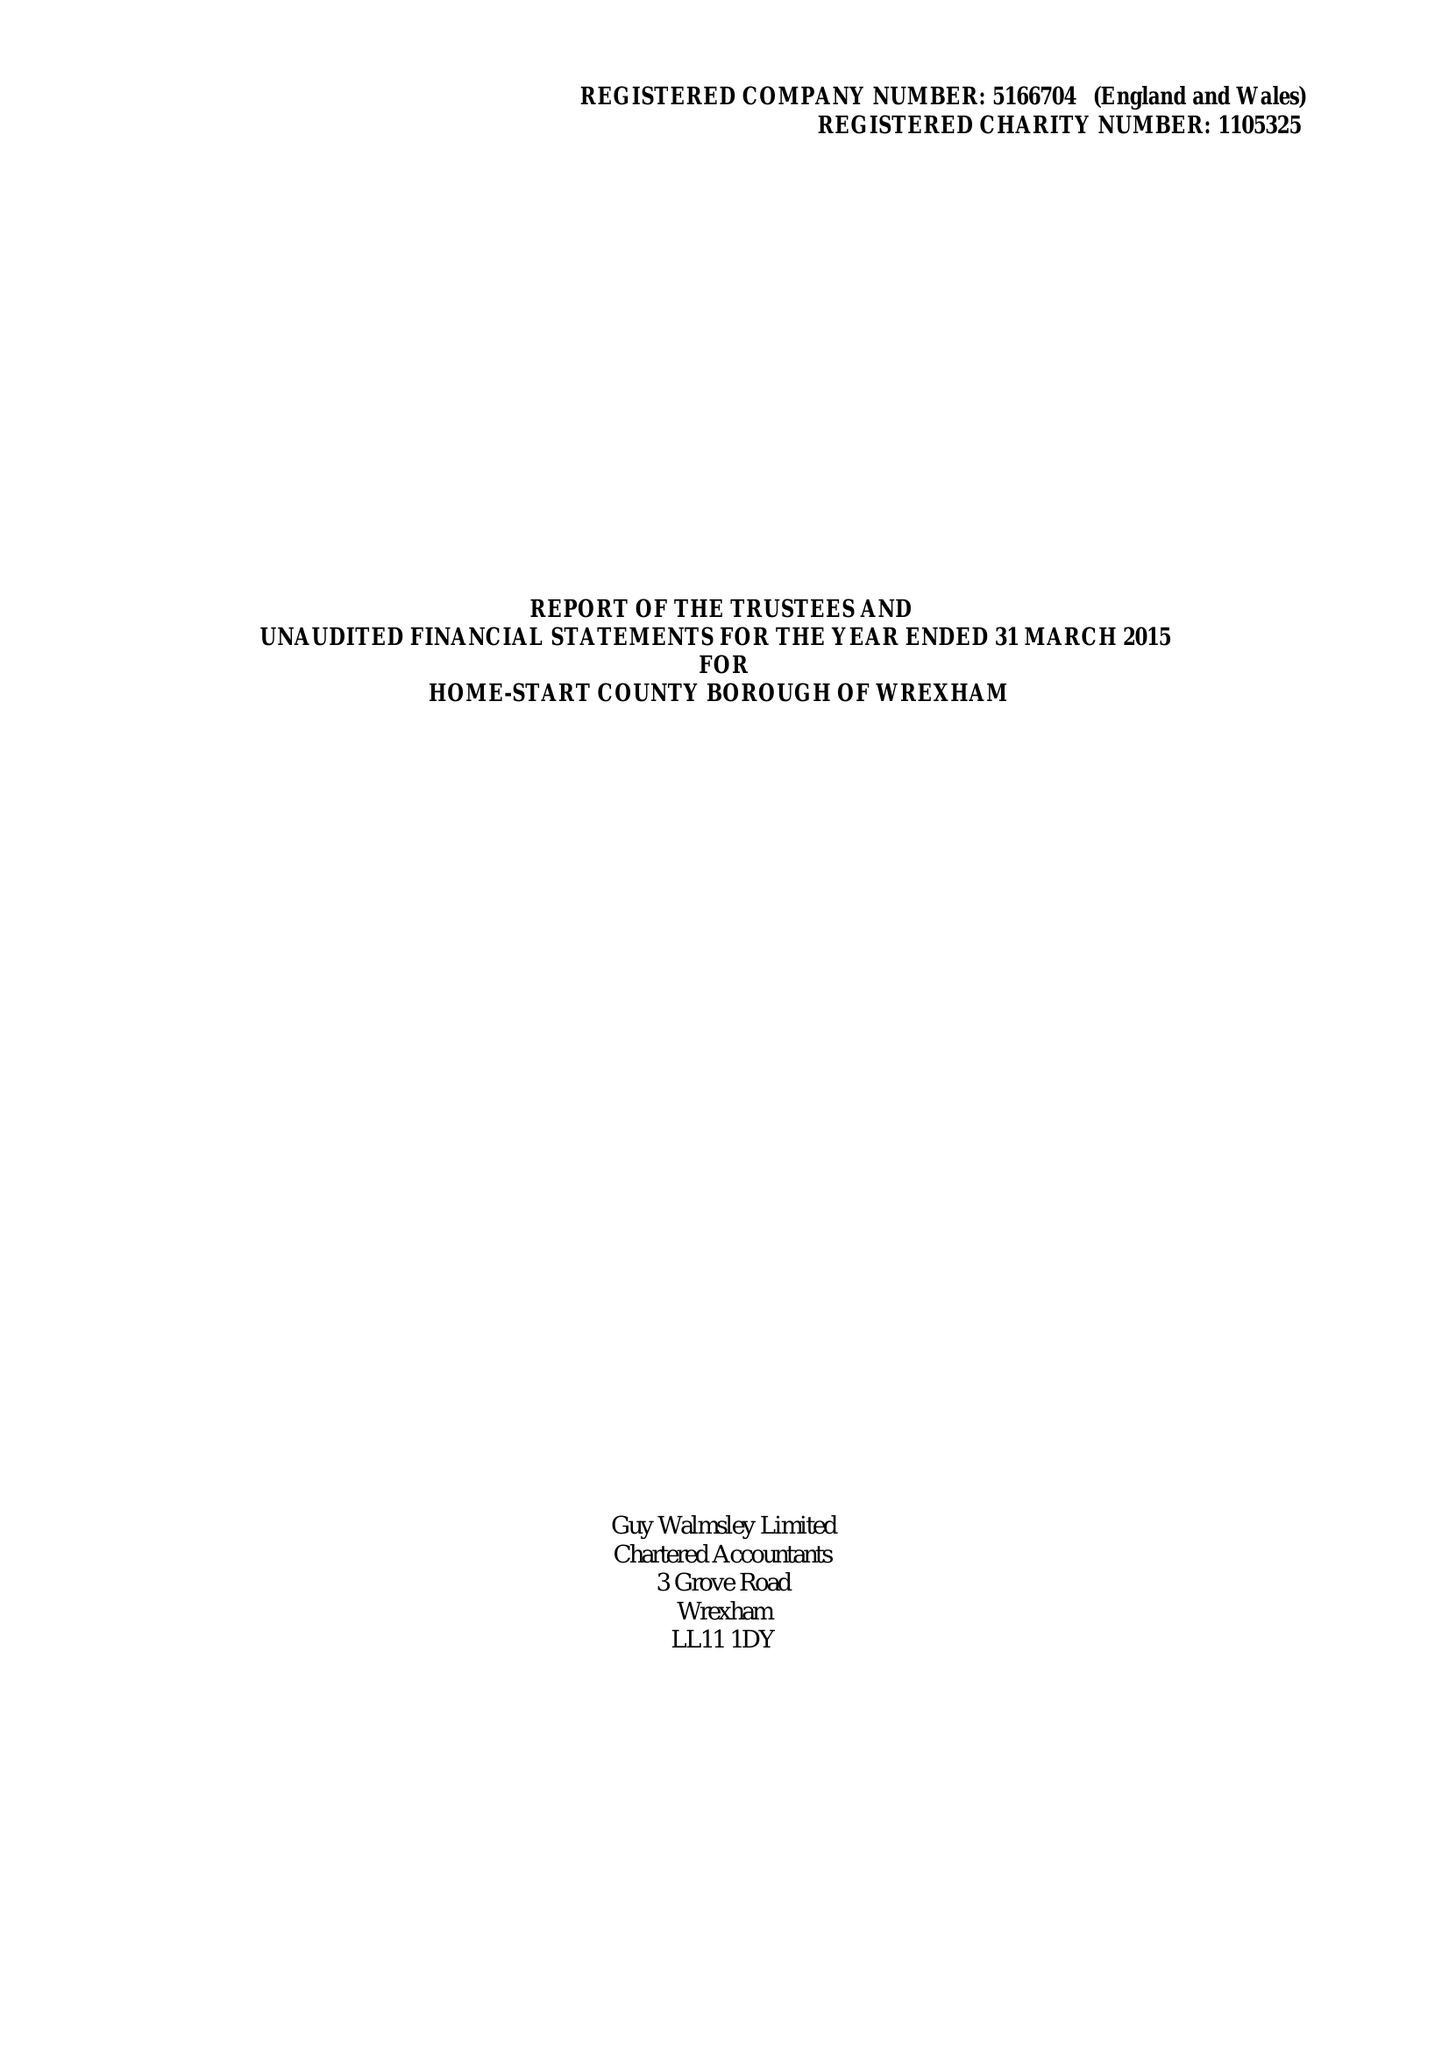What is the value for the report_date?
Answer the question using a single word or phrase. 2015-03-31 